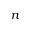<formula> <loc_0><loc_0><loc_500><loc_500>n</formula> 